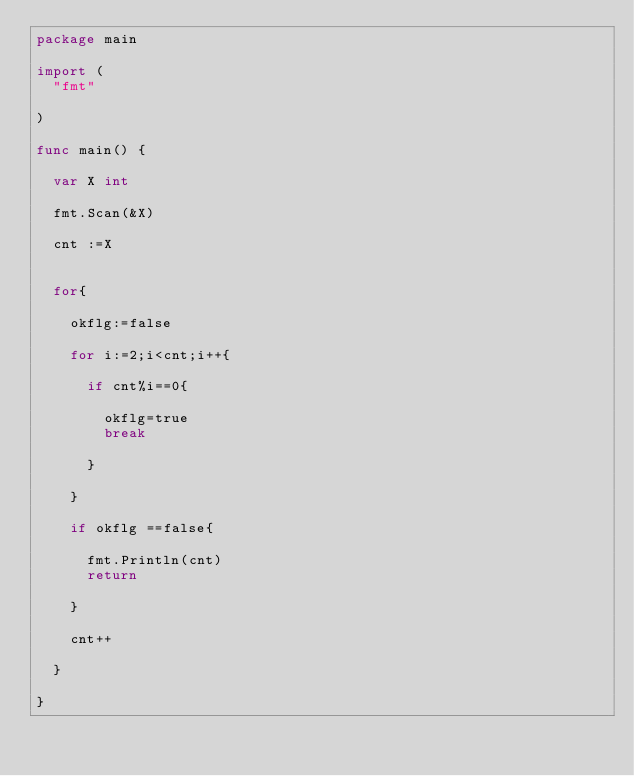Convert code to text. <code><loc_0><loc_0><loc_500><loc_500><_Go_>package main

import (
	"fmt"

)

func main() {

	var X int

	fmt.Scan(&X)

	cnt :=X


	for{

		okflg:=false

		for i:=2;i<cnt;i++{

			if cnt%i==0{

				okflg=true
				break
				
			}

		}

		if okflg ==false{

			fmt.Println(cnt)
			return

		}

		cnt++

	}

}</code> 